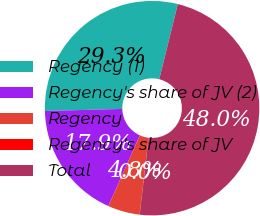<chart> <loc_0><loc_0><loc_500><loc_500><pie_chart><fcel>Regency (1)<fcel>Regency's share of JV (2)<fcel>Regency<fcel>Regency's share of JV<fcel>Total<nl><fcel>29.28%<fcel>17.89%<fcel>4.82%<fcel>0.03%<fcel>47.98%<nl></chart> 